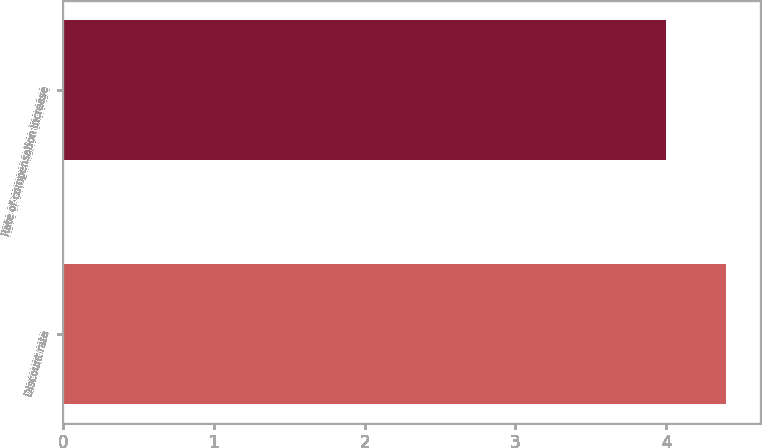<chart> <loc_0><loc_0><loc_500><loc_500><bar_chart><fcel>Discount rate<fcel>Rate of compensation increase<nl><fcel>4.4<fcel>4<nl></chart> 